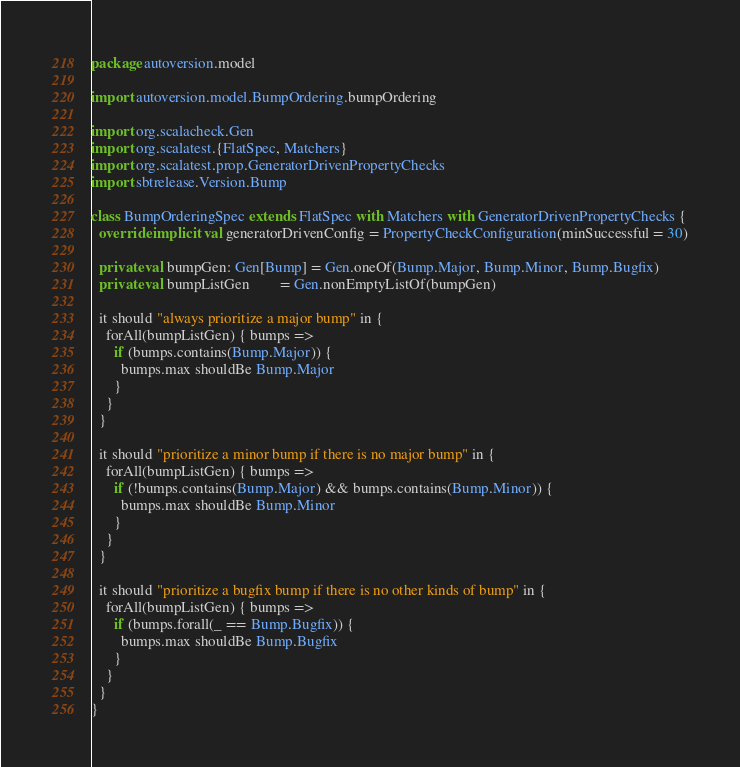Convert code to text. <code><loc_0><loc_0><loc_500><loc_500><_Scala_>package autoversion.model

import autoversion.model.BumpOrdering.bumpOrdering

import org.scalacheck.Gen
import org.scalatest.{FlatSpec, Matchers}
import org.scalatest.prop.GeneratorDrivenPropertyChecks
import sbtrelease.Version.Bump

class BumpOrderingSpec extends FlatSpec with Matchers with GeneratorDrivenPropertyChecks {
  override implicit val generatorDrivenConfig = PropertyCheckConfiguration(minSuccessful = 30)

  private val bumpGen: Gen[Bump] = Gen.oneOf(Bump.Major, Bump.Minor, Bump.Bugfix)
  private val bumpListGen        = Gen.nonEmptyListOf(bumpGen)

  it should "always prioritize a major bump" in {
    forAll(bumpListGen) { bumps =>
      if (bumps.contains(Bump.Major)) {
        bumps.max shouldBe Bump.Major
      }
    }
  }

  it should "prioritize a minor bump if there is no major bump" in {
    forAll(bumpListGen) { bumps =>
      if (!bumps.contains(Bump.Major) && bumps.contains(Bump.Minor)) {
        bumps.max shouldBe Bump.Minor
      }
    }
  }

  it should "prioritize a bugfix bump if there is no other kinds of bump" in {
    forAll(bumpListGen) { bumps =>
      if (bumps.forall(_ == Bump.Bugfix)) {
        bumps.max shouldBe Bump.Bugfix
      }
    }
  }
}
</code> 